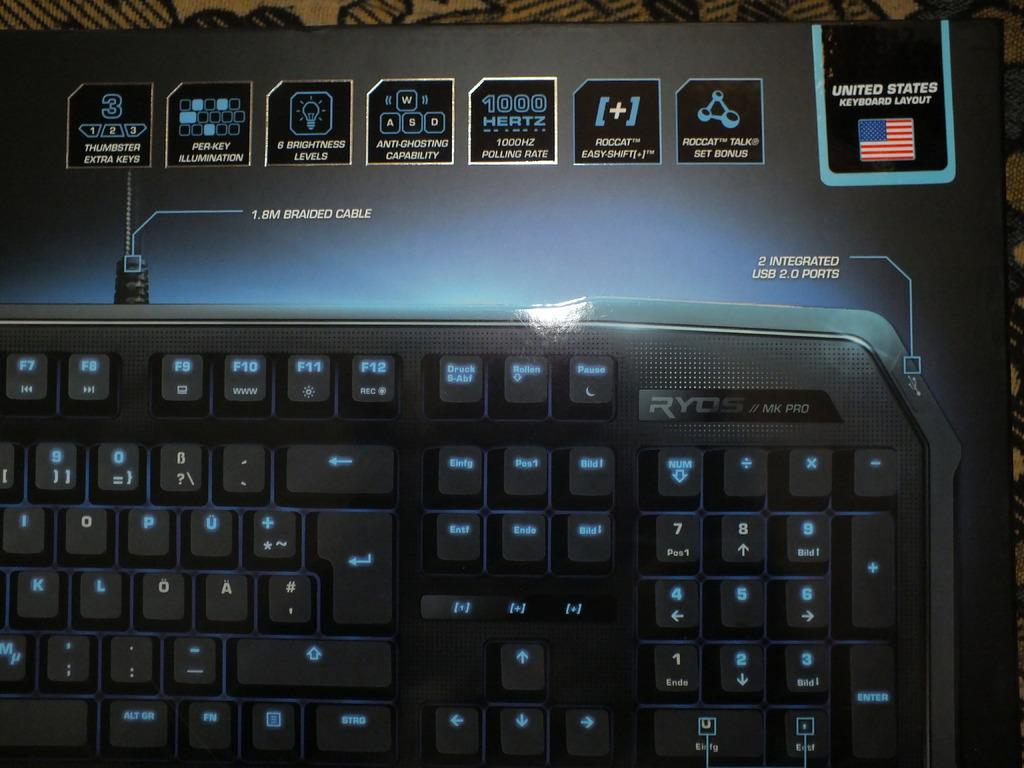<image>
Relay a brief, clear account of the picture shown. A black and blue keyboard that has a United States layout. 